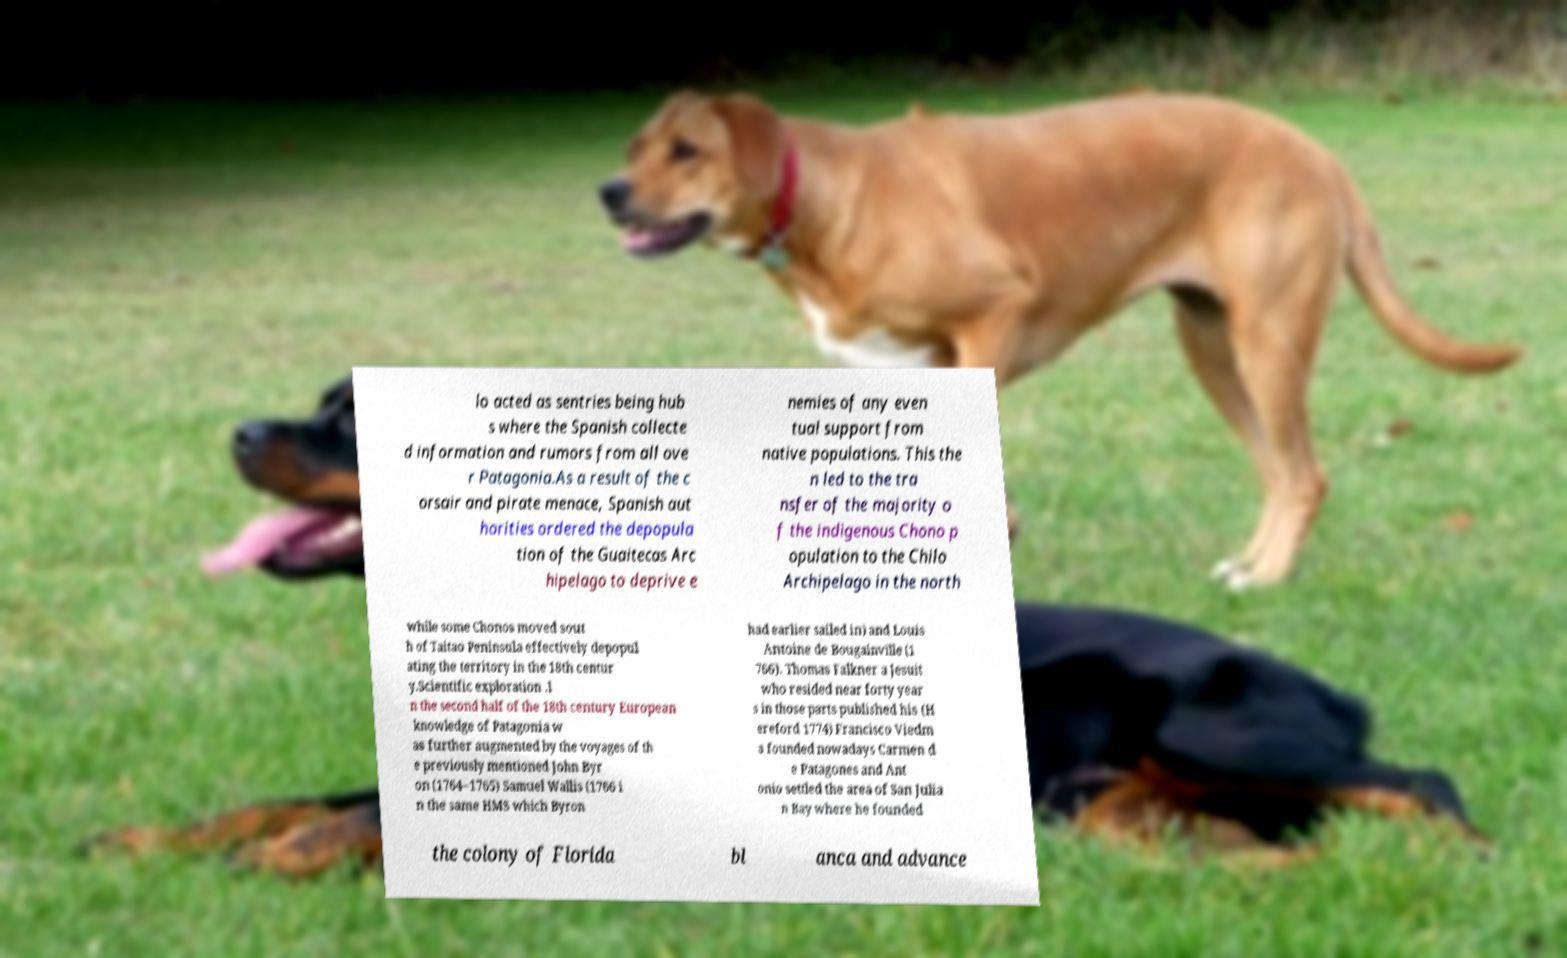Please identify and transcribe the text found in this image. lo acted as sentries being hub s where the Spanish collecte d information and rumors from all ove r Patagonia.As a result of the c orsair and pirate menace, Spanish aut horities ordered the depopula tion of the Guaitecas Arc hipelago to deprive e nemies of any even tual support from native populations. This the n led to the tra nsfer of the majority o f the indigenous Chono p opulation to the Chilo Archipelago in the north while some Chonos moved sout h of Taitao Peninsula effectively depopul ating the territory in the 18th centur y.Scientific exploration .I n the second half of the 18th century European knowledge of Patagonia w as further augmented by the voyages of th e previously mentioned John Byr on (1764–1765) Samuel Wallis (1766 i n the same HMS which Byron had earlier sailed in) and Louis Antoine de Bougainville (1 766). Thomas Falkner a Jesuit who resided near forty year s in those parts published his (H ereford 1774) Francisco Viedm a founded nowadays Carmen d e Patagones and Ant onio settled the area of San Julia n Bay where he founded the colony of Florida bl anca and advance 